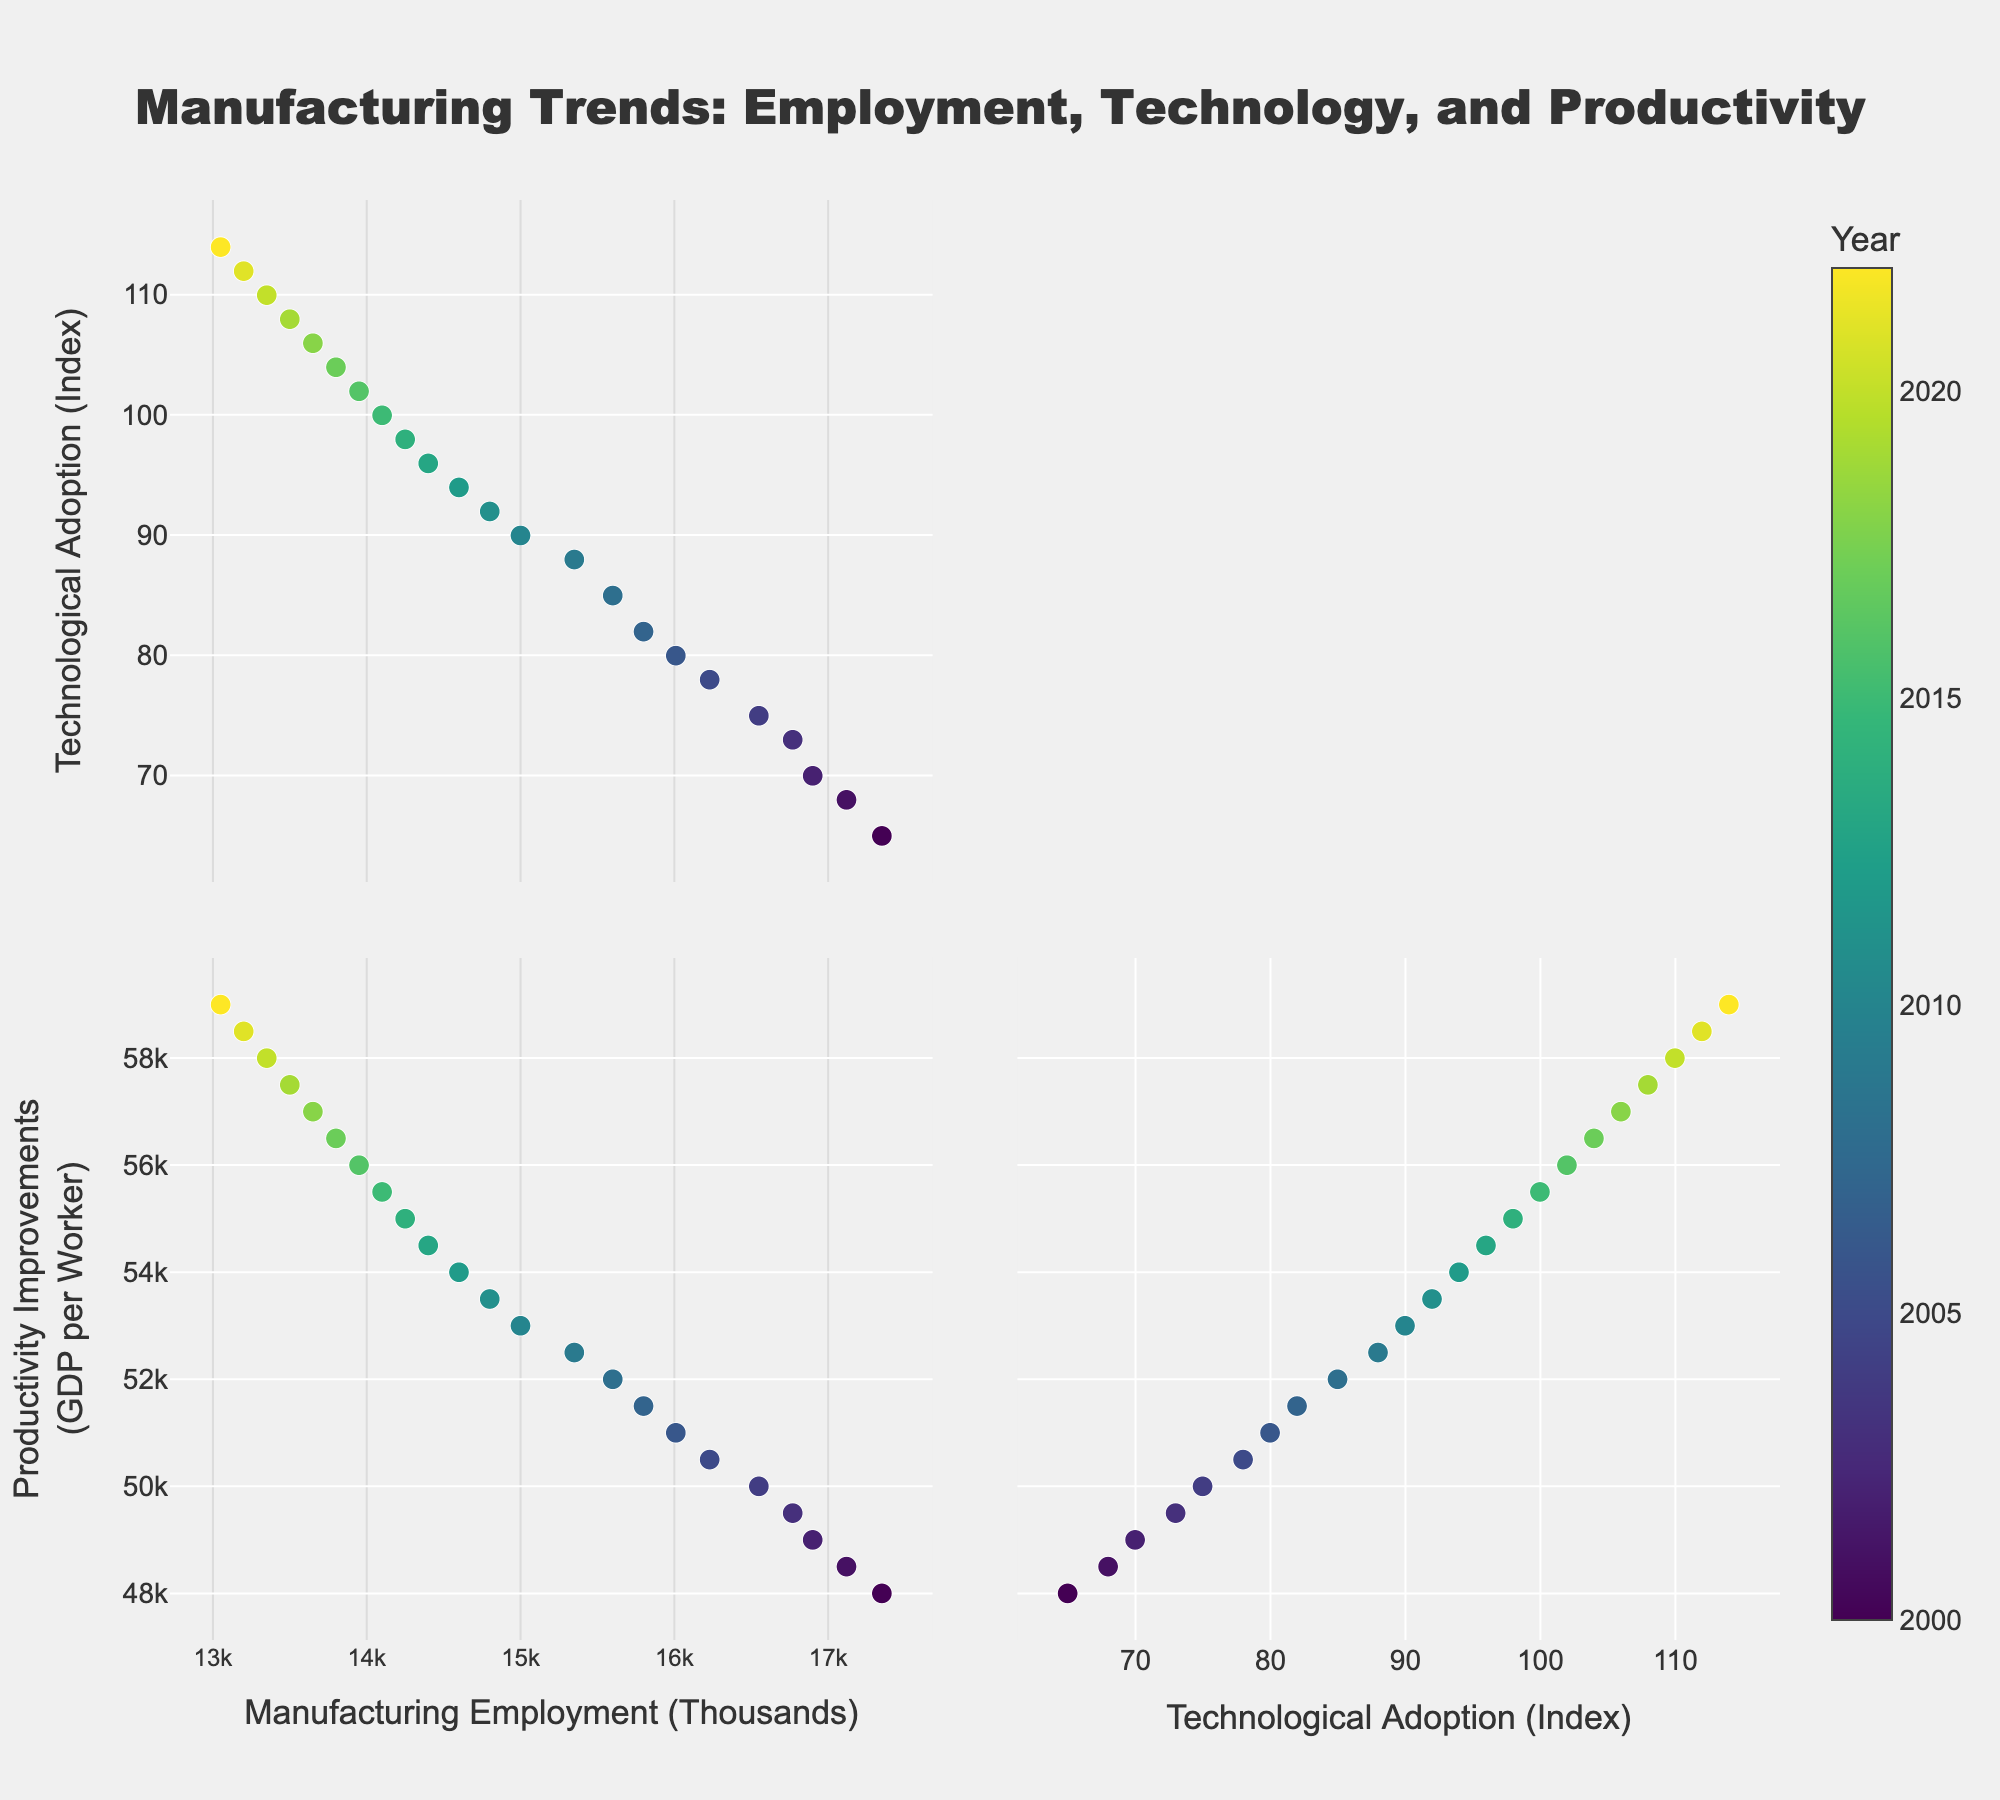What is the title of the scatter plot matrix? The title of the figure is typically displayed prominently at the top of the plot. By looking at the SPLOM, we can see that the title is "Manufacturing Trends: Employment, Technology, and Productivity".
Answer: Manufacturing Trends: Employment, Technology, and Productivity How many dimensions are being compared in the scatter plot matrix? Each axis corresponds to a different dimension. In the figure, we can see axes for Manufacturing Employment, Technological Adoption, and Productivity Improvements, totaling three dimensions.
Answer: Three Which year had the lowest Manufacturing Employment? By observing the scatter plot for the Manufacturing Employment dimension, find the data point with the smallest value and check its year in the color bar/table. The lowest Manufacturing Employment is in 2022.
Answer: 2022 What color points represent the year 2000? The color representing the year 2000 can be identified by checking the color scale of the scatter plot matrix legend. It shows a relatively lighter tone at the beginning of the Viridis color gradient.
Answer: Lighter tone (near the start of the color gradient) How does Technological Adoption correlate with Manufacturing Employment over the years? Observing the scatter plot between Technological Adoption and Manufacturing Employment, check the trend line or overall relationship (positive/negative correlation). There's a visible negative correlation, meaning as Technological Adoption increases, Manufacturing Employment tends to decrease.
Answer: Negative correlation Is 2010 closer to the beginning or the end of the color gradient? By examining the color gradient scale, we can see that 2010 is midway through the Viridis color scale, indicating it's neither at the beginning nor the endpoint but rather in the middle.
Answer: Middle What is the Technological Adoption index for the year 2015? Locate the Technological Adoption index for the year 2015 on the appropriate axis/dimension in the scatter plot. It corresponds to 100.
Answer: 100 Which dimension shows the most significant increase over time? Examine the scatter plots to identify which dimension has data points that trend sharply upwards over time. Productivity Improvements show the most significant increase.
Answer: Productivity Improvements Do Manufacturing Employment and Productivity Improvements display the same trend? Assess the scatter plots for Manufacturing Employment and Productivity Improvements. Manufacturing Employment trends downward, while Productivity Improvements trend upward, indicating different trends.
Answer: Different trends What is the productivity level in GDP per worker for the year 2021? Identify the data point for the year 2021 in the scatter plot for Productivity Improvements. It is 58,500.
Answer: 58,500 